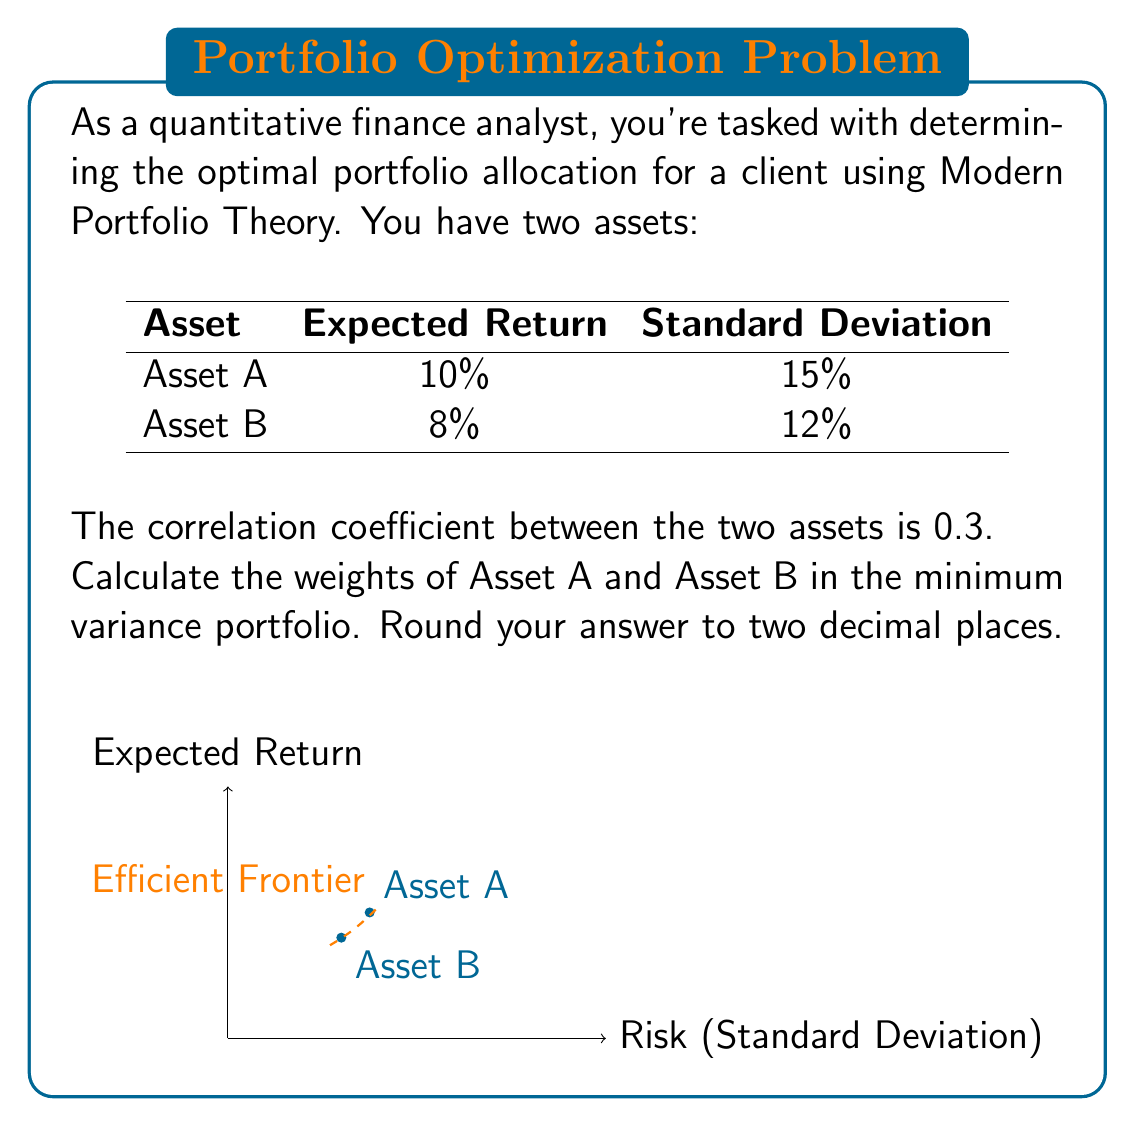Teach me how to tackle this problem. To solve this problem using Modern Portfolio Theory, we'll follow these steps:

1) First, recall the formula for the variance of a two-asset portfolio:

   $$\sigma_p^2 = w_A^2\sigma_A^2 + w_B^2\sigma_B^2 + 2w_Aw_B\sigma_A\sigma_B\rho_{AB}$$

   where $w_A$ and $w_B$ are the weights of assets A and B, $\sigma_A$ and $\sigma_B$ are their standard deviations, and $\rho_{AB}$ is their correlation coefficient.

2) For the minimum variance portfolio, we need to find the weight of Asset A ($w_A$) that minimizes this variance. We can do this by taking the derivative of $\sigma_p^2$ with respect to $w_A$ and setting it to zero:

   $$\frac{d\sigma_p^2}{dw_A} = 2w_A\sigma_A^2 + 2(1-w_A)\sigma_B^2\rho_{AB} - 2w_A\sigma_B^2 + 2\sigma_A\sigma_B\rho_{AB} = 0$$

3) Solving this equation for $w_A$:

   $$w_A = \frac{\sigma_B^2 - \sigma_A\sigma_B\rho_{AB}}{\sigma_A^2 + \sigma_B^2 - 2\sigma_A\sigma_B\rho_{AB}}$$

4) Now, let's plug in our values:
   $\sigma_A = 15\%$, $\sigma_B = 12\%$, $\rho_{AB} = 0.3$

   $$w_A = \frac{0.12^2 - 0.15 \cdot 0.12 \cdot 0.3}{0.15^2 + 0.12^2 - 2 \cdot 0.15 \cdot 0.12 \cdot 0.3} = 0.3913$$

5) Round to two decimal places: $w_A = 0.39$

6) Since the weights must sum to 1, $w_B = 1 - w_A = 1 - 0.39 = 0.61$

Therefore, the minimum variance portfolio consists of 39% in Asset A and 61% in Asset B.
Answer: Asset A: 0.39, Asset B: 0.61 